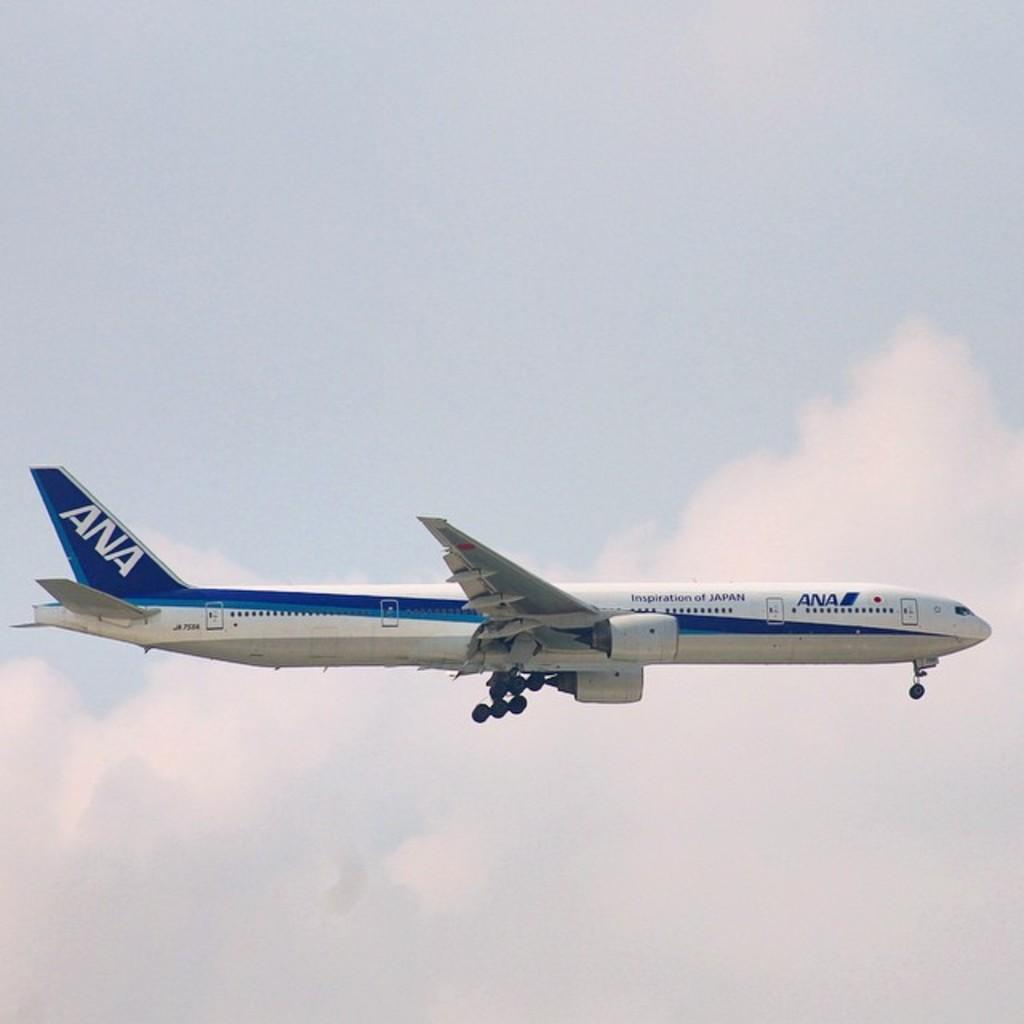<image>
Offer a succinct explanation of the picture presented. A blue and white airplane with Ana Airlines on it. 